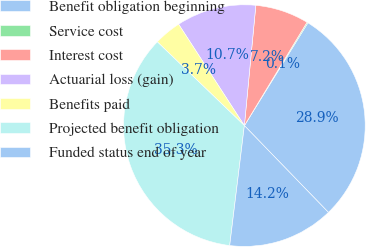Convert chart. <chart><loc_0><loc_0><loc_500><loc_500><pie_chart><fcel>Benefit obligation beginning<fcel>Service cost<fcel>Interest cost<fcel>Actuarial loss (gain)<fcel>Benefits paid<fcel>Projected benefit obligation<fcel>Funded status end of year<nl><fcel>28.94%<fcel>0.14%<fcel>7.16%<fcel>10.67%<fcel>3.65%<fcel>35.25%<fcel>14.18%<nl></chart> 